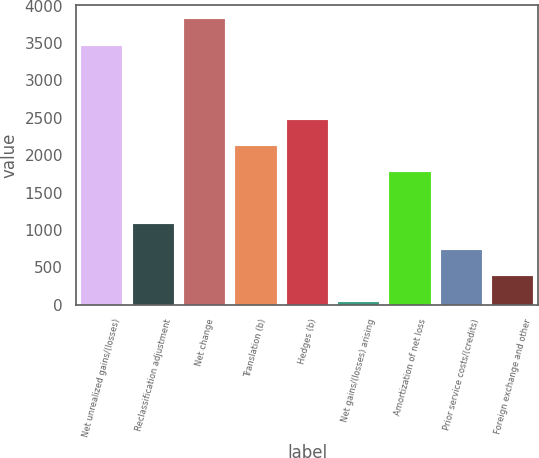Convert chart. <chart><loc_0><loc_0><loc_500><loc_500><bar_chart><fcel>Net unrealized gains/(losses)<fcel>Reclassification adjustment<fcel>Net change<fcel>Translation (b)<fcel>Hedges (b)<fcel>Net gains/(losses) arising<fcel>Amortization of net loss<fcel>Prior service costs/(credits)<fcel>Foreign exchange and other<nl><fcel>3465.8<fcel>1075.4<fcel>3814.6<fcel>2121.8<fcel>2470.6<fcel>29<fcel>1773<fcel>726.6<fcel>377.8<nl></chart> 